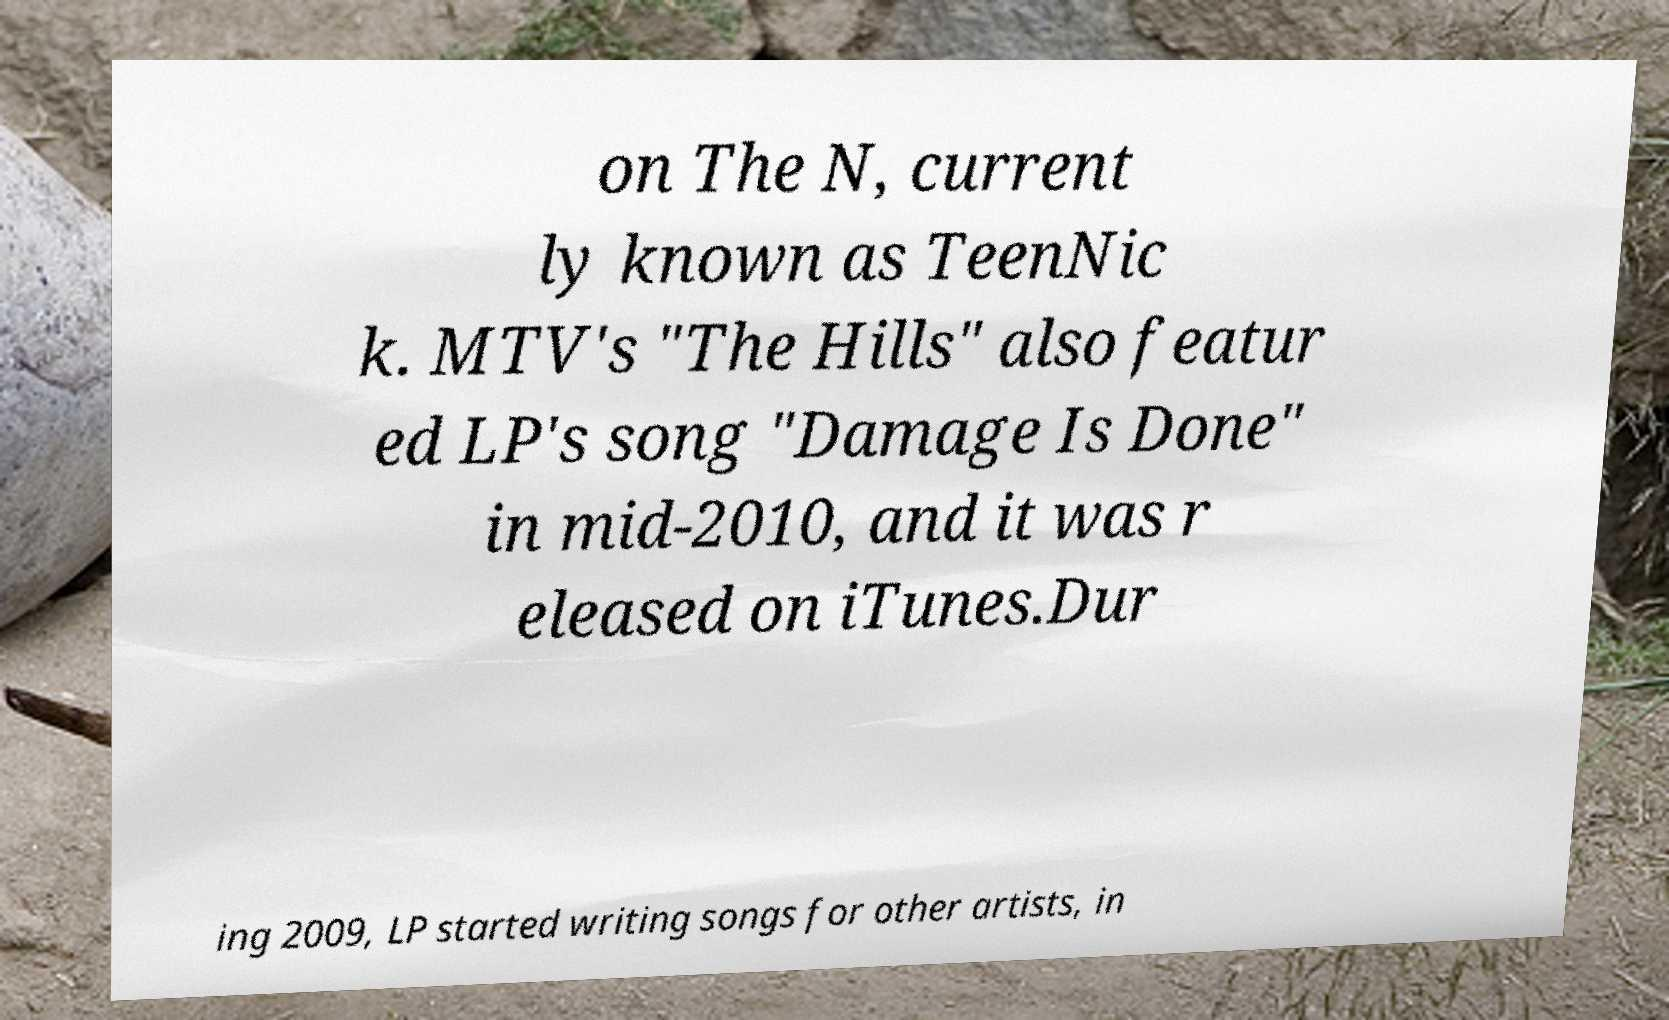There's text embedded in this image that I need extracted. Can you transcribe it verbatim? on The N, current ly known as TeenNic k. MTV's "The Hills" also featur ed LP's song "Damage Is Done" in mid-2010, and it was r eleased on iTunes.Dur ing 2009, LP started writing songs for other artists, in 